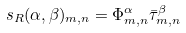Convert formula to latex. <formula><loc_0><loc_0><loc_500><loc_500>\ s _ { R } ( \alpha , \beta ) _ { m , n } = \Phi ^ { \alpha } _ { m , n } \bar { \tau } ^ { \beta } _ { m , n }</formula> 